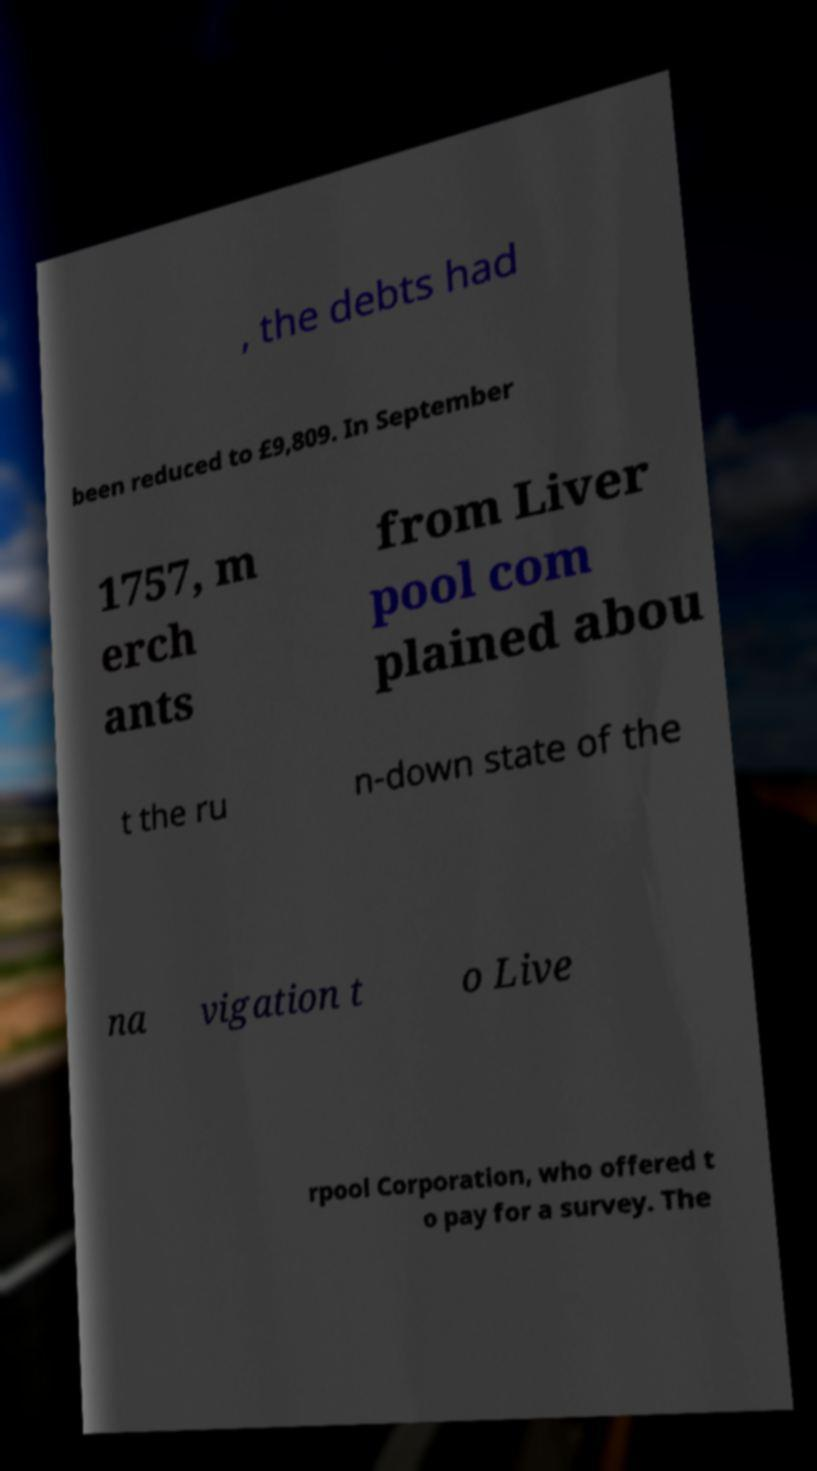Please read and relay the text visible in this image. What does it say? , the debts had been reduced to £9,809. In September 1757, m erch ants from Liver pool com plained abou t the ru n-down state of the na vigation t o Live rpool Corporation, who offered t o pay for a survey. The 